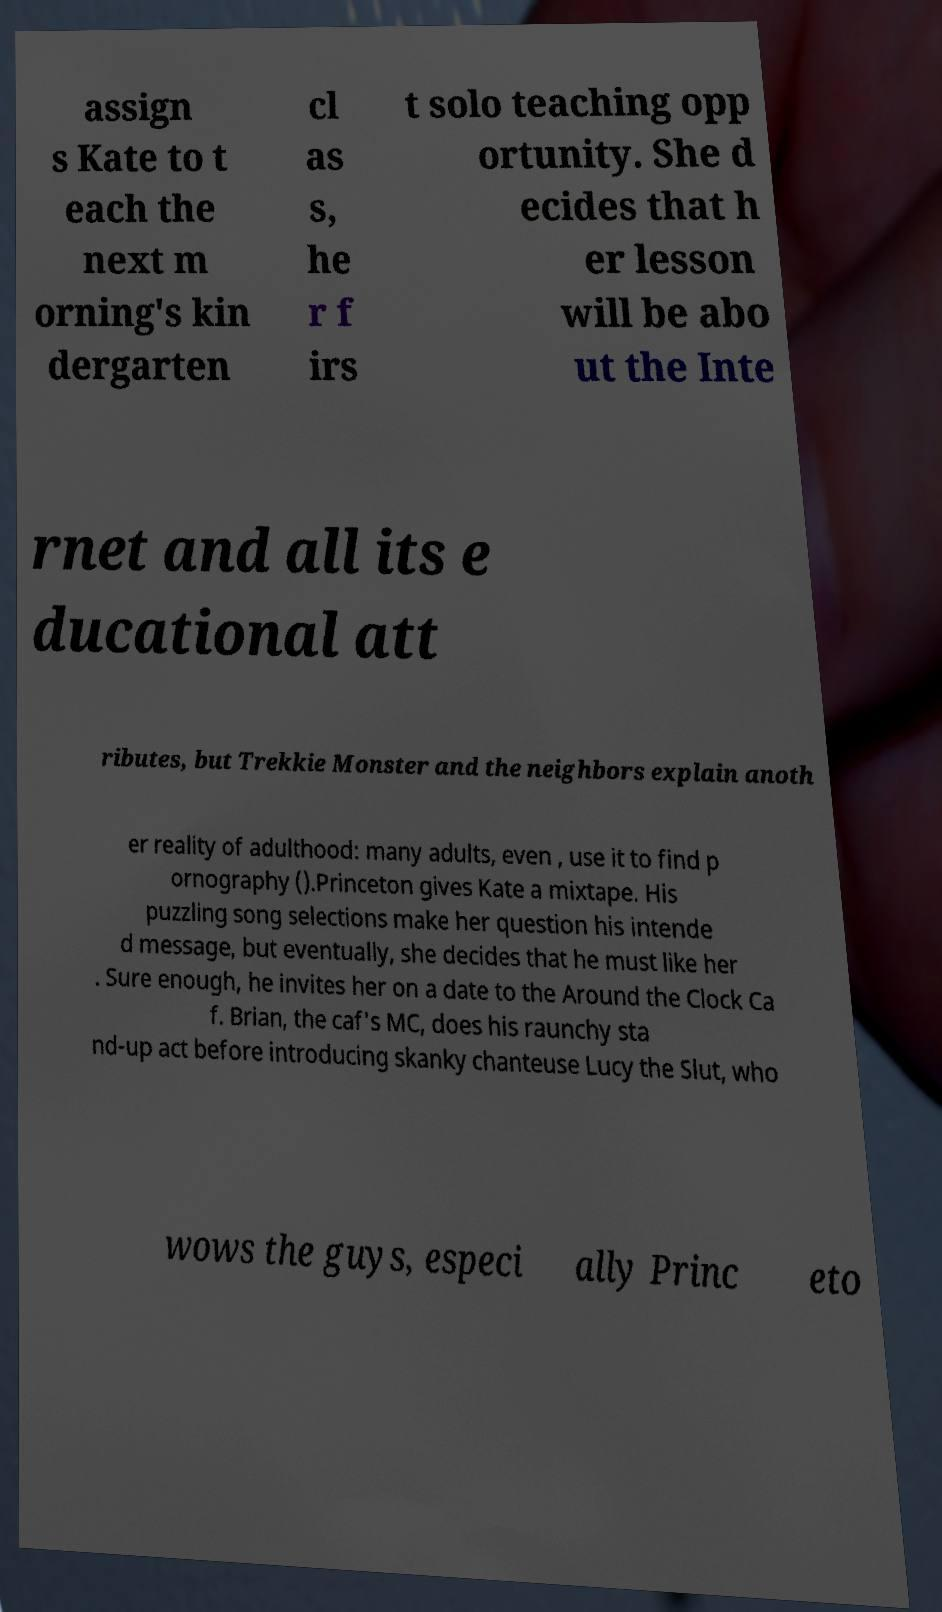Could you assist in decoding the text presented in this image and type it out clearly? assign s Kate to t each the next m orning's kin dergarten cl as s, he r f irs t solo teaching opp ortunity. She d ecides that h er lesson will be abo ut the Inte rnet and all its e ducational att ributes, but Trekkie Monster and the neighbors explain anoth er reality of adulthood: many adults, even , use it to find p ornography ().Princeton gives Kate a mixtape. His puzzling song selections make her question his intende d message, but eventually, she decides that he must like her . Sure enough, he invites her on a date to the Around the Clock Ca f. Brian, the caf's MC, does his raunchy sta nd-up act before introducing skanky chanteuse Lucy the Slut, who wows the guys, especi ally Princ eto 